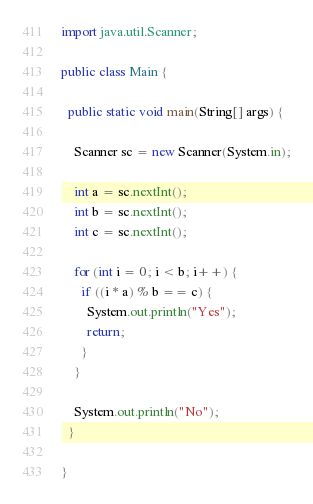Convert code to text. <code><loc_0><loc_0><loc_500><loc_500><_Java_>import java.util.Scanner;

public class Main {

  public static void main(String[] args) {

    Scanner sc = new Scanner(System.in);

    int a = sc.nextInt();
    int b = sc.nextInt();
    int c = sc.nextInt();

    for (int i = 0; i < b; i++) {
      if ((i * a) % b == c) {
        System.out.println("Yes");
        return;
      }
    }

    System.out.println("No");
  }

}</code> 